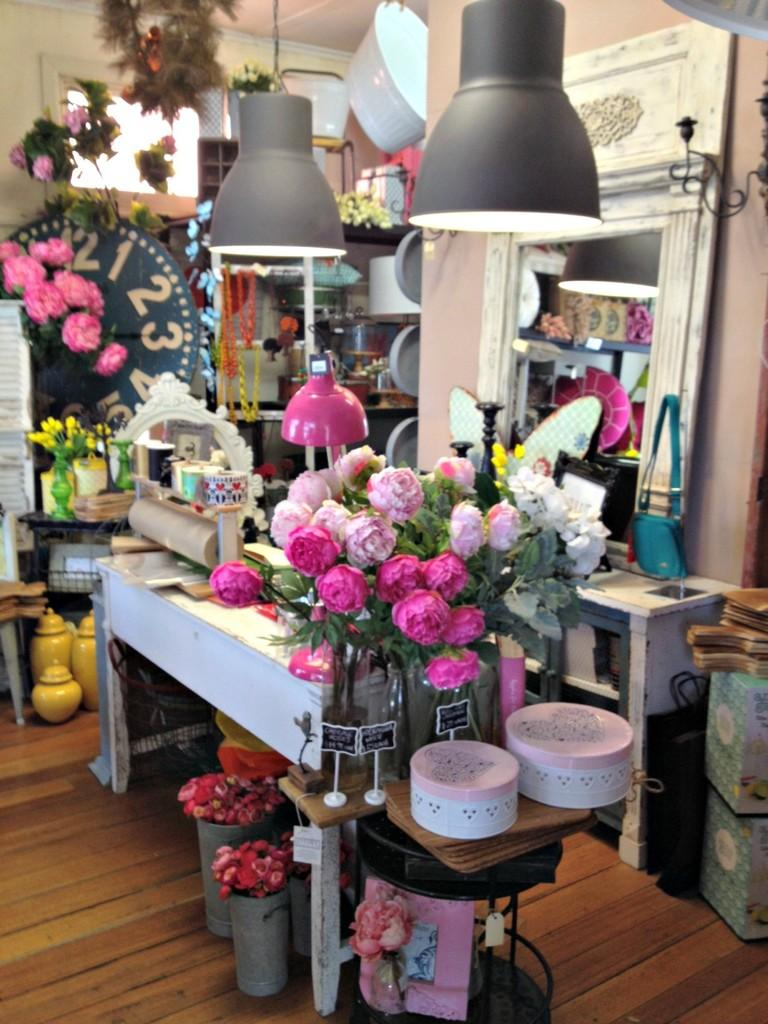What can be seen on the table in the image? There are flowers on the table. What can be seen illuminating the scene in the image? There are lights visible in the image. What is located in the background of the image? There is a flower vase and handmade jars in the background. What type of train can be seen passing by in the image? There is no train present in the image. What kind of test is being conducted in the image? There is no test being conducted in the image. 